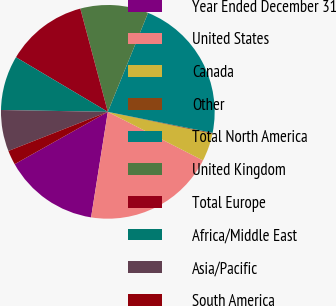Convert chart. <chart><loc_0><loc_0><loc_500><loc_500><pie_chart><fcel>Year Ended December 31<fcel>United States<fcel>Canada<fcel>Other<fcel>Total North America<fcel>United Kingdom<fcel>Total Europe<fcel>Africa/Middle East<fcel>Asia/Pacific<fcel>South America<nl><fcel>14.35%<fcel>19.99%<fcel>4.21%<fcel>0.15%<fcel>22.01%<fcel>10.29%<fcel>12.32%<fcel>8.26%<fcel>6.24%<fcel>2.18%<nl></chart> 